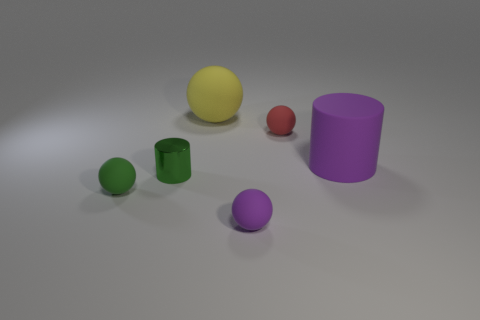Can you tell me the arrangement of the items in respect to the largest yellow sphere? Certainly! The arrangement of items around the largest yellow sphere is such that directly to its left is a smaller green cylinder with a glossy surface, and to its right, at a slight diagonal, rests a small red sphere. Behind the yellow sphere, centrally aligned in the image, is a large matte purple cylinder, and further behind it to the right, sits a medium-sized purple sphere. 